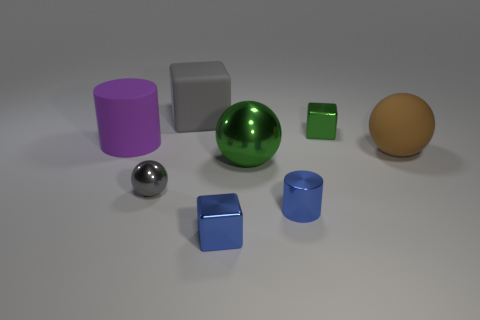Can you tell me how many objects are there in total and describe their colors and shapes? Certainly! There are eight objects in total. Starting from the left, there is a purple cylinder, a large silver sphere, a small gray cube, a green sphere, a large gray cube, a small green cube, a small blue cylinder, and a yellow ellipsoid. Each object has its own unique color and geometric shape. 